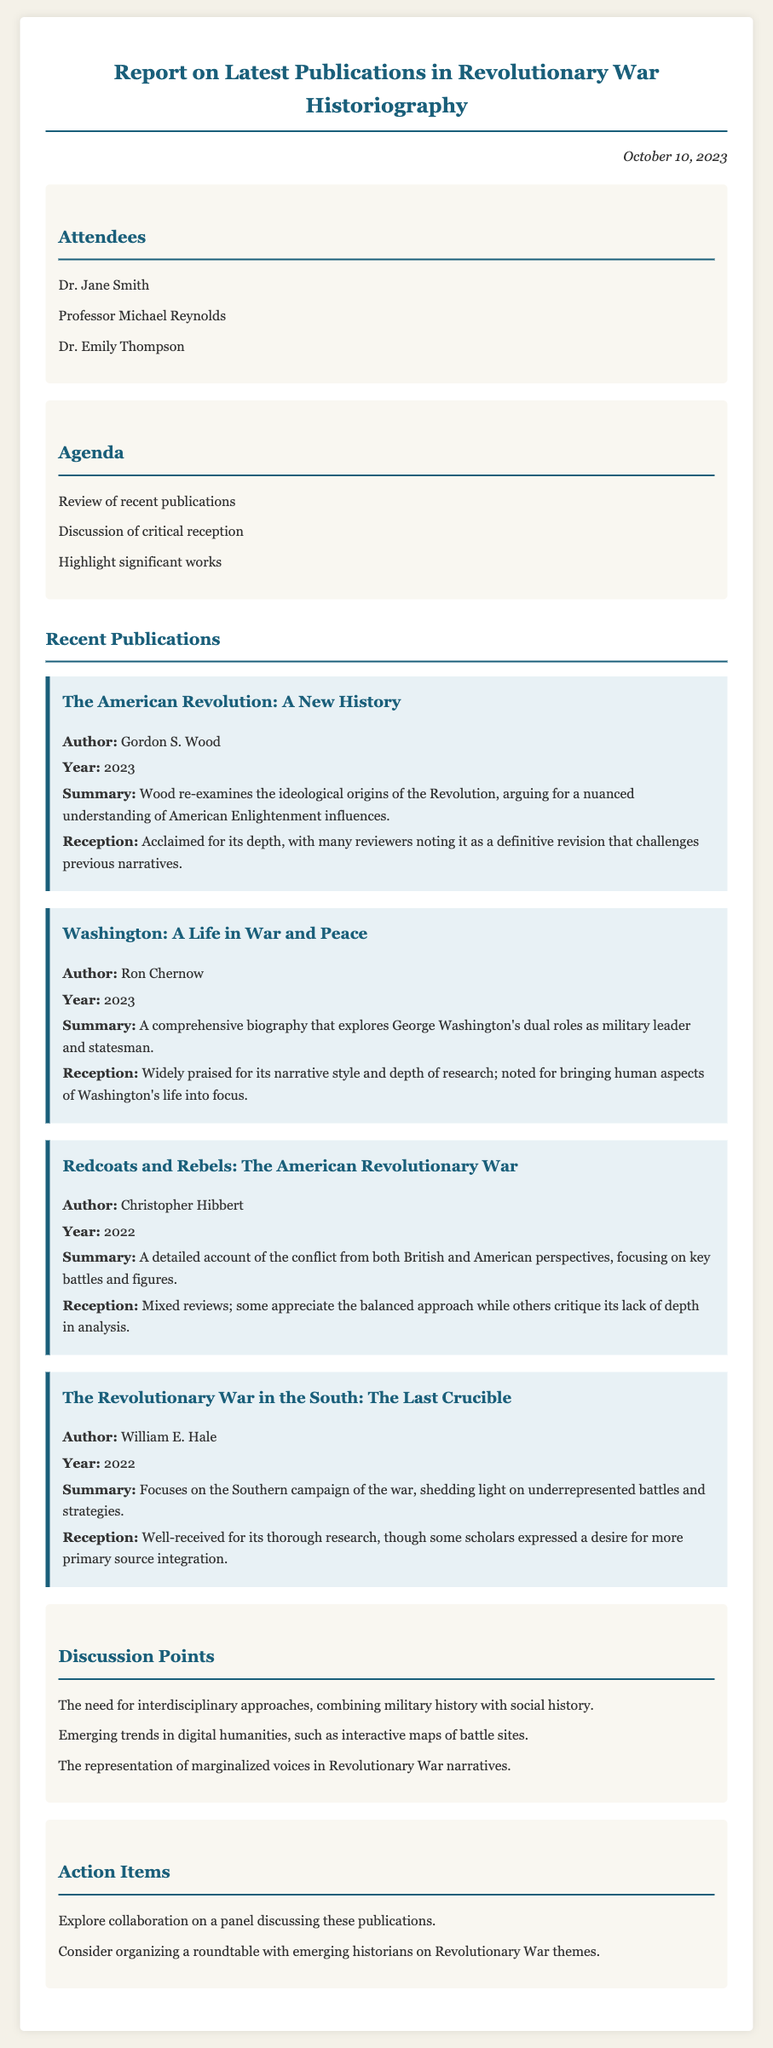What is the date of the meeting? The date is explicitly mentioned at the top of the document.
Answer: October 10, 2023 Who is the author of "Washington: A Life in War and Peace"? The author's name is revealed in the section detailing recent publications.
Answer: Ron Chernow What major theme is discussed concerning historiography? The discussion points highlight key themes related to historiography in the document.
Answer: Interdisciplinary approaches In what year was "The Revolutionary War in the South: The Last Crucible" published? The publication year is noted in the summary of the respective work.
Answer: 2022 How many attendees were present at the meeting? The list of attendees is provided at the beginning of the document.
Answer: Three What is the main focus of "The American Revolution: A New History"? The summary provides insight into the central theme of the publication.
Answer: Ideological origins of the Revolution What action item is suggested regarding collaboration? The action items section lists potential collaborative efforts.
Answer: Panel discussing these publications Who authored "Redcoats and Rebels: The American Revolutionary War"? The author's name is specified in the publication details.
Answer: Christopher Hibbert 